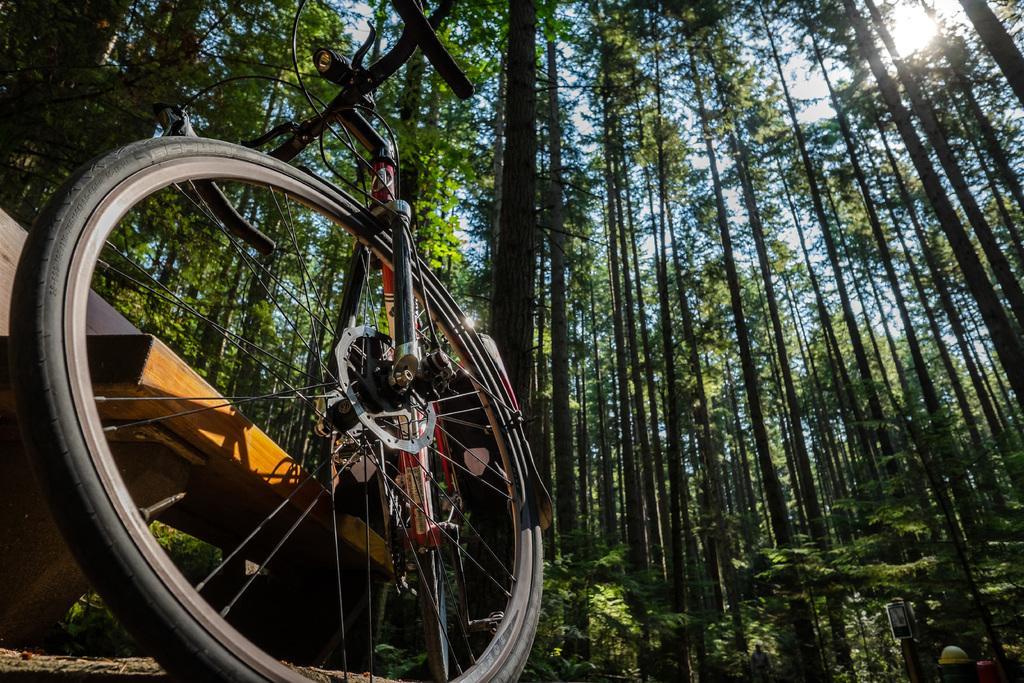Could you give a brief overview of what you see in this image? In the image we can see a bicycle and this is a wheel of a bicycle. There are many trees and a sky. 